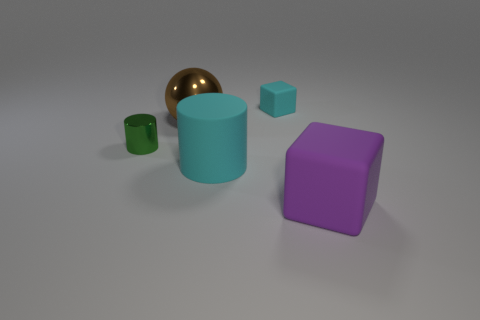Add 4 big cyan cylinders. How many objects exist? 9 Subtract all cylinders. How many objects are left? 3 Subtract 0 green balls. How many objects are left? 5 Subtract all large spheres. Subtract all tiny yellow shiny objects. How many objects are left? 4 Add 2 metallic balls. How many metallic balls are left? 3 Add 3 purple cubes. How many purple cubes exist? 4 